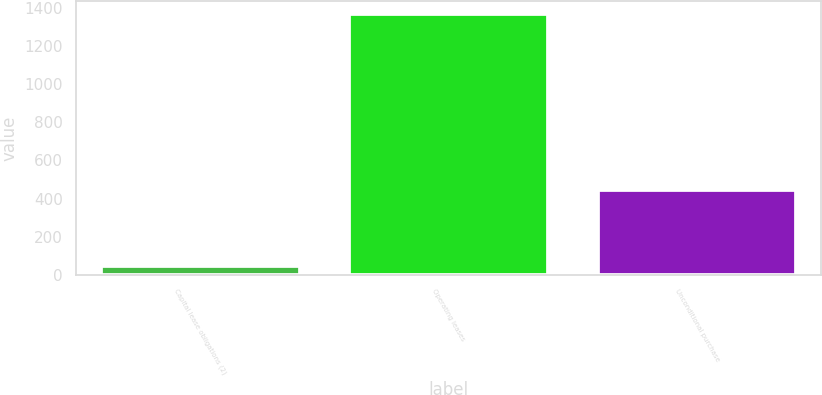<chart> <loc_0><loc_0><loc_500><loc_500><bar_chart><fcel>Capital lease obligations (2)<fcel>Operating leases<fcel>Unconditional purchase<nl><fcel>44<fcel>1368<fcel>446<nl></chart> 